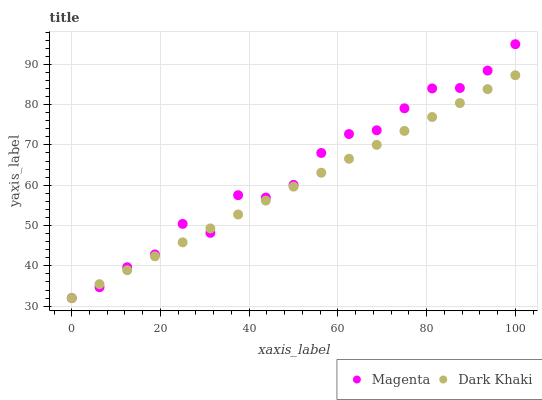Does Dark Khaki have the minimum area under the curve?
Answer yes or no. Yes. Does Magenta have the maximum area under the curve?
Answer yes or no. Yes. Does Magenta have the minimum area under the curve?
Answer yes or no. No. Is Dark Khaki the smoothest?
Answer yes or no. Yes. Is Magenta the roughest?
Answer yes or no. Yes. Is Magenta the smoothest?
Answer yes or no. No. Does Dark Khaki have the lowest value?
Answer yes or no. Yes. Does Magenta have the highest value?
Answer yes or no. Yes. Does Dark Khaki intersect Magenta?
Answer yes or no. Yes. Is Dark Khaki less than Magenta?
Answer yes or no. No. Is Dark Khaki greater than Magenta?
Answer yes or no. No. 